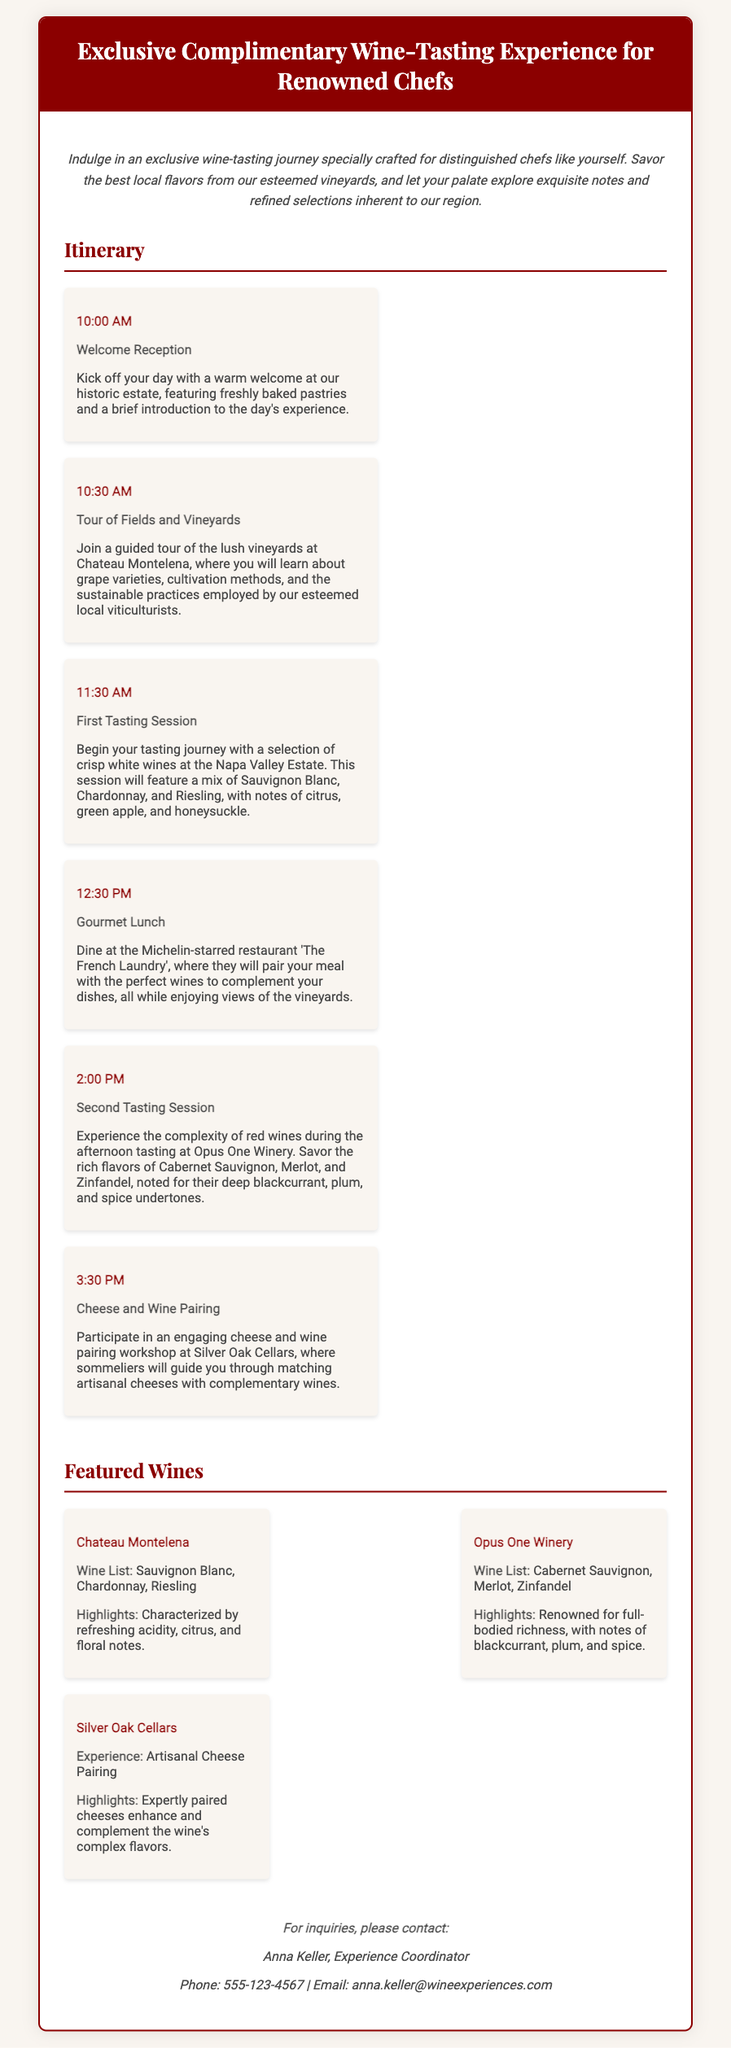What is the title of the voucher? The title of the voucher indicates the type of experience being offered.
Answer: Exclusive Complimentary Wine-Tasting Experience for Renowned Chefs What time does the welcome reception start? The start time of the welcome reception is specified in the itinerary section.
Answer: 10:00 AM Which winery features the first tasting session? The question asks for the specific winery where the first tasting occurs.
Answer: Napa Valley Estate What type of wine is highlighted from Chateau Montelena? The document specifies the type of wine from this winery in the featured wines section.
Answer: Sauvignon Blanc, Chardonnay, Riesling What activity occurs at 2:00 PM? The time of the activity helps identify its nature from the itinerary.
Answer: Second Tasting Session How many different varieties of wine will be tasted throughout the day? This question involves reasoning through the itinerary to count the different wines mentioned.
Answer: Six What is the name of the experience coordinator? This asks for the specific individual mentioned for inquiries at the end of the document.
Answer: Anna Keller What kind of lunch will participants enjoy? The type of lunch indicates the prestige of the dining experience included in the itinerary.
Answer: Gourmet Lunch What is the focus of the workshop at Silver Oak Cellars? This question requires understanding the type of activity scheduled at this location.
Answer: Cheese and Wine Pairing 